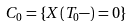Convert formula to latex. <formula><loc_0><loc_0><loc_500><loc_500>C _ { 0 } = \{ X ( T _ { 0 } - ) = 0 \}</formula> 